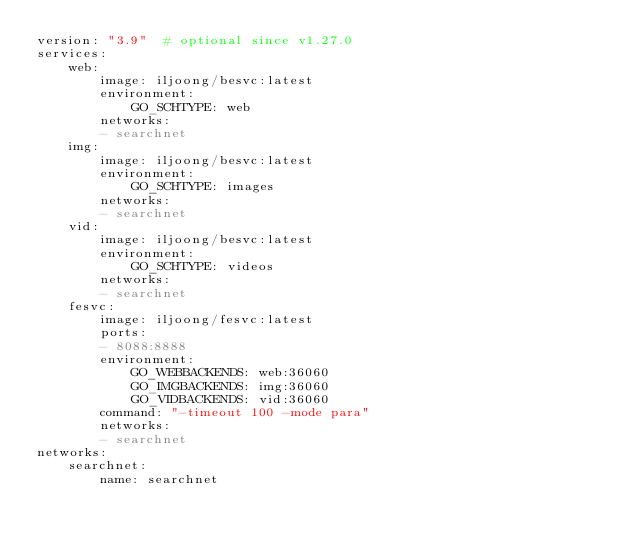<code> <loc_0><loc_0><loc_500><loc_500><_YAML_>version: "3.9"  # optional since v1.27.0
services:
    web:
        image: iljoong/besvc:latest
        environment:
            GO_SCHTYPE: web
        networks:
        - searchnet
    img:
        image: iljoong/besvc:latest
        environment:
            GO_SCHTYPE: images
        networks:
        - searchnet
    vid:
        image: iljoong/besvc:latest
        environment:
            GO_SCHTYPE: videos
        networks:
        - searchnet
    fesvc:
        image: iljoong/fesvc:latest
        ports:
        - 8088:8888
        environment:
            GO_WEBBACKENDS: web:36060
            GO_IMGBACKENDS: img:36060
            GO_VIDBACKENDS: vid:36060
        command: "-timeout 100 -mode para"
        networks:
        - searchnet   
networks:
    searchnet:
        name: searchnet
</code> 